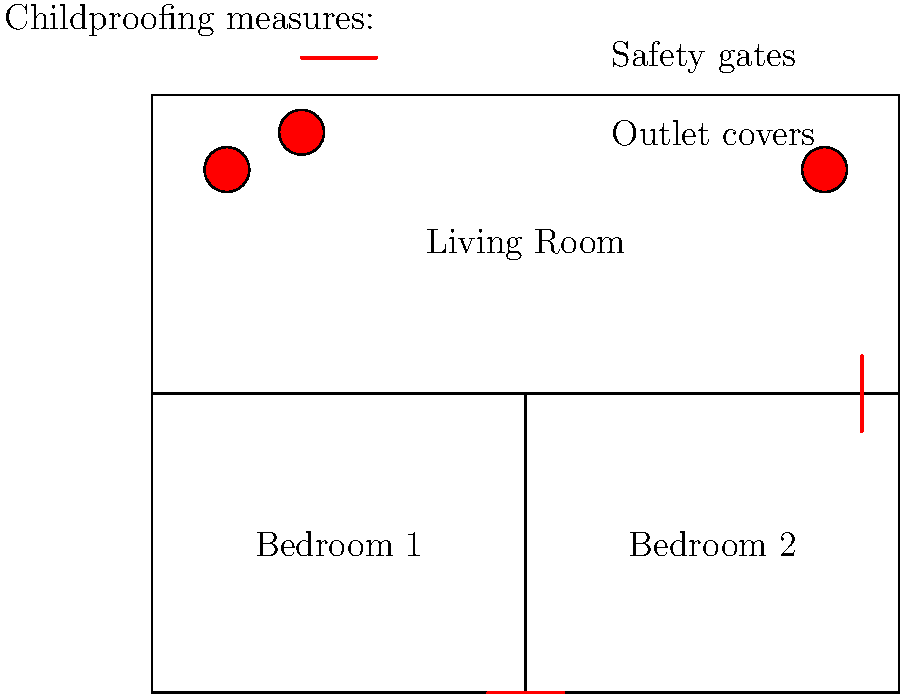In the floor plan of a typical Southside home, how many childproofing measures are highlighted, and what are they? To answer this question, we need to carefully examine the floor plan and identify the highlighted childproofing measures:

1. Safety gates: There are two red lines in the floor plan that represent safety gates.
   a. One is located between the two bedrooms (at the bottom of the image).
   b. Another is at the entrance to the living room (on the right side of the image).

2. Outlet covers: There are two red circles in the living room area that represent outlet covers.

Therefore, we can identify a total of two types of childproofing measures:
1. Safety gates (2 instances)
2. Outlet covers (2 instances)

The total number of highlighted childproofing measures is 4 (2 safety gates + 2 outlet covers).
Answer: 4 measures: 2 safety gates and 2 outlet covers 